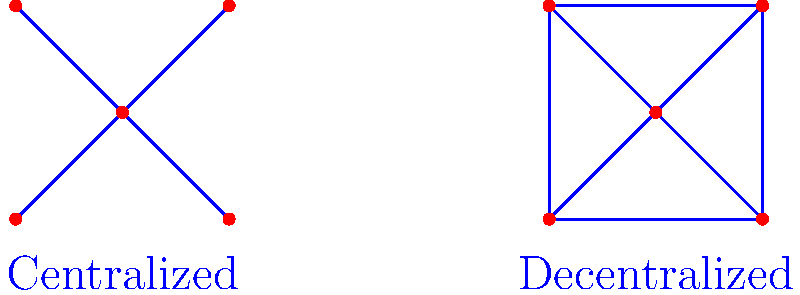Analyze the two network architectures depicted in the diagram. Which structure is more resilient to single node failures, and why is this characteristic important in the context of political systems and governance? To answer this question, let's analyze both network architectures step-by-step:

1. Centralized Network:
   - Has one central node connected to all other nodes
   - All communication goes through the central node
   - If the central node fails, the entire network is disrupted

2. Decentralized Network:
   - Each node is connected to multiple other nodes
   - Communication can take multiple paths between nodes
   - If one node fails, the network can still function

3. Resilience to single node failures:
   - The decentralized network is more resilient
   - In a centralized network, failure of the central node is catastrophic
   - In a decentralized network, failure of any single node has limited impact

4. Importance in political systems and governance:
   - Resilience translates to stability in governance
   - Decentralized systems (e.g., federalism) can better withstand local crises
   - Power distribution in decentralized systems prevents single points of failure
   - Promotes checks and balances, reducing risks of autocracy

5. Examples in political contexts:
   - Centralized: Authoritarian regimes, highly centralized governments
   - Decentralized: Federal systems, democratic structures with separation of powers

In conclusion, the decentralized network architecture is more resilient to single node failures. This characteristic is crucial in political systems as it promotes stability, prevents power concentration, and enhances the system's ability to withstand crises or failures in individual components of the governance structure.
Answer: Decentralized network; promotes stability and prevents single points of failure in governance. 